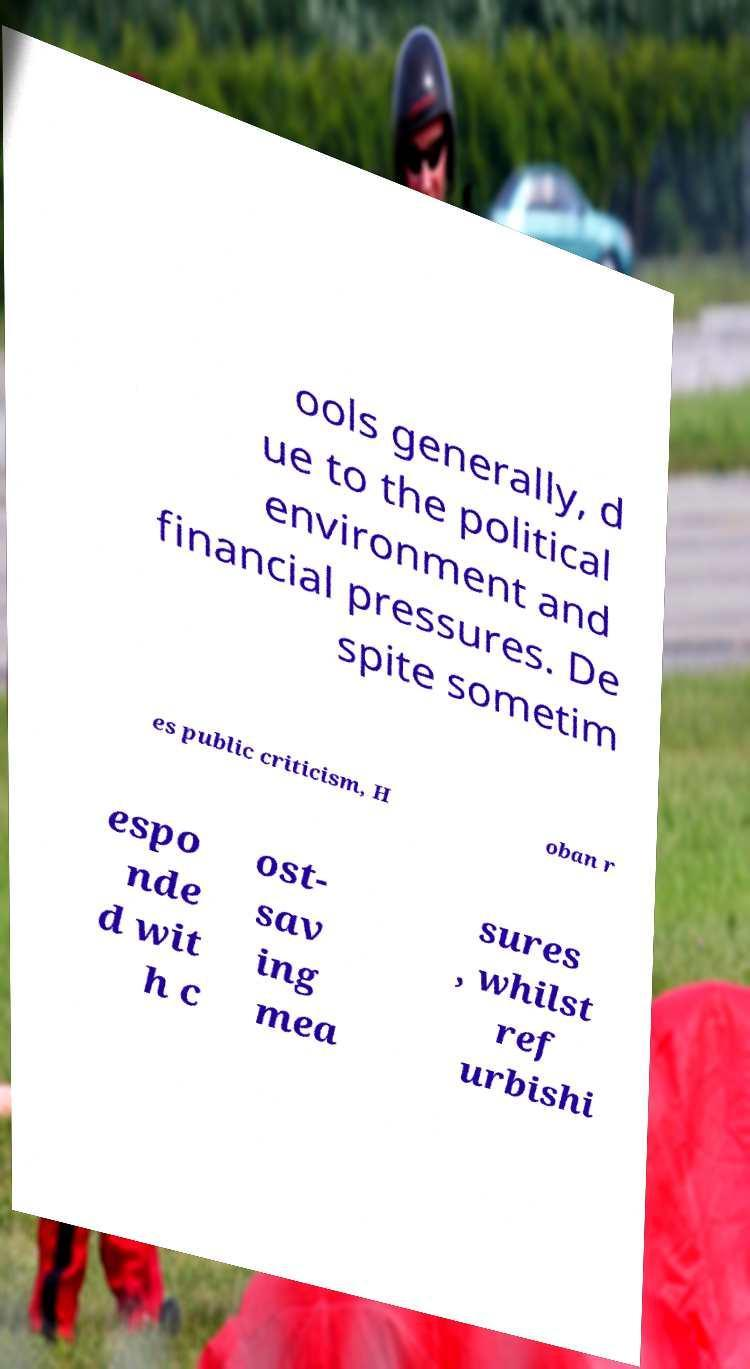Could you extract and type out the text from this image? ools generally, d ue to the political environment and financial pressures. De spite sometim es public criticism, H oban r espo nde d wit h c ost- sav ing mea sures , whilst ref urbishi 